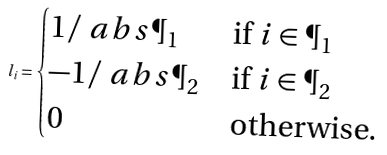Convert formula to latex. <formula><loc_0><loc_0><loc_500><loc_500>l _ { i } = \begin{cases} 1 / \ a b s { \P _ { 1 } } & \text {if $i \in \P_{1}$} \\ - 1 / \ a b s { \P _ { 2 } } & \text {if $i \in \P_{2}$} \\ 0 & \text {otherwise.} \end{cases}</formula> 